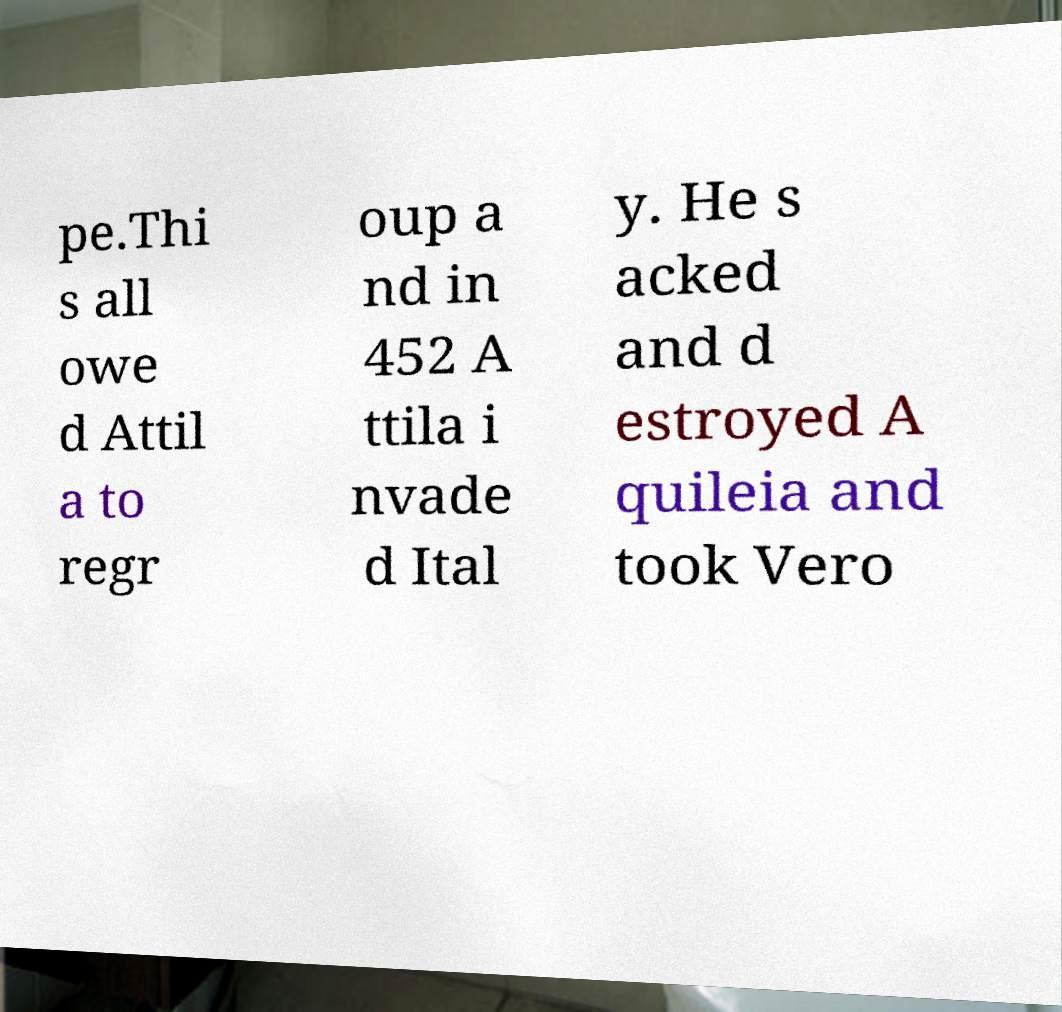Can you read and provide the text displayed in the image?This photo seems to have some interesting text. Can you extract and type it out for me? pe.Thi s all owe d Attil a to regr oup a nd in 452 A ttila i nvade d Ital y. He s acked and d estroyed A quileia and took Vero 